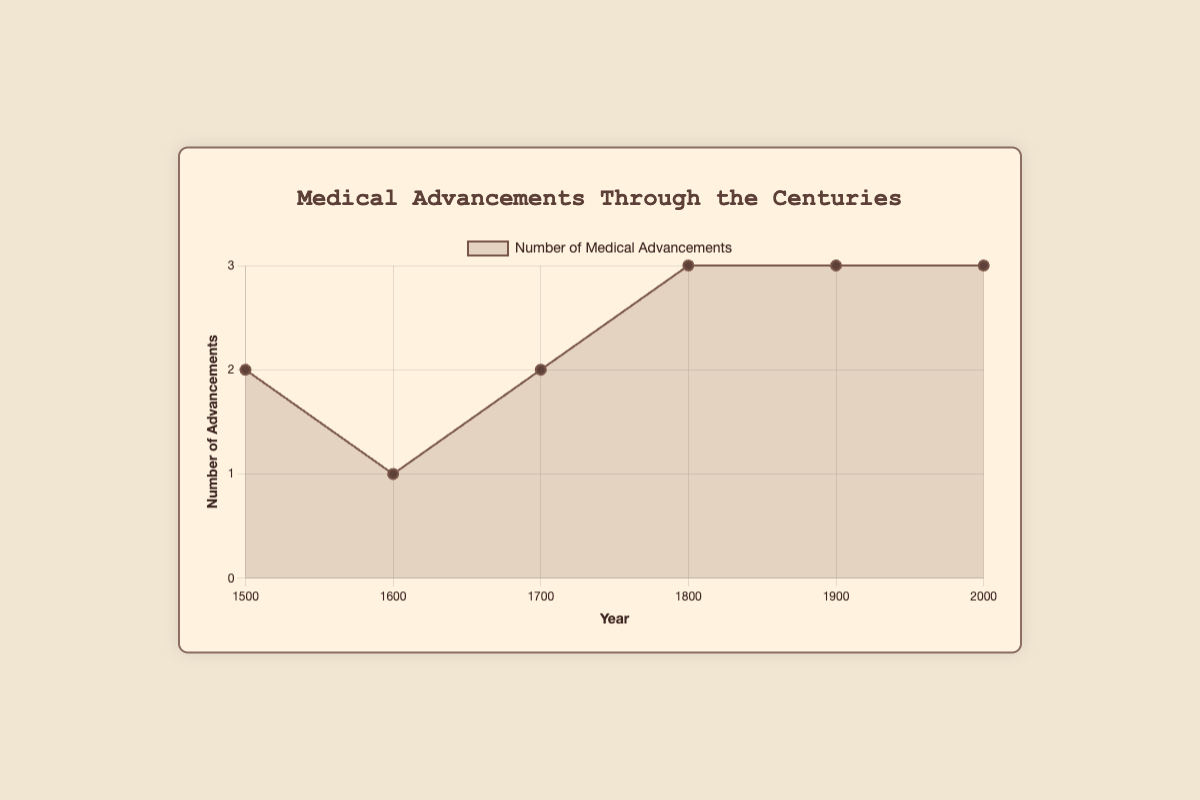What's the trend in the number of medical advancements from the year 1500 to 2000? Look at the line chart, it shows an increasing trend in the number of medical advancements over the centuries. It starts with 2 advancements around 1500, rising to 3 by 1800, and peaking at 3 in 1900 and 2000.
Answer: Increasing Which century saw the greatest increase in the number of medical advancements compared to the previous century? Compare the differences in the number of advancements between consecutive centuries visible in the line chart. From 1600 to 1700, it increases by 1 advancement; from 1700 to 1800, it increases by 1 more advancement; from 1800 to 1900, it increases by 1 advancement; and from 1900 to 2000, it remains the same. The century with the greatest increase is from 1500 to 1600 with an increase of 1.
Answer: From 1500 to 1600 How many medical innovations were introduced in the 20th century (1900s)? Refer to the y-axis value for the year 1900 in the line chart. Three innovations were introduced during this period.
Answer: Three Compare the number of medical advancements in the year 1500 and 1800. Which year had more, and by how much? Look at the y-axis values for both 1500 and 1800. The year 1500 had 2 advancements, and the year 1800 had 3 advancements. 1800 had one more advancement than 1500.
Answer: 1800 by 1 Was there any century with no recorded medical advancements? If so, which one? By inspecting the line chart, each century from 1500 to 2000 has at least one recorded medical advancement. Therefore, there is no century with zero advancements.
Answer: No What’s the average number of medical advancements per century from 1500 to 2000? Sum up the number of advancements from each century (2 + 1 + 2 + 3 + 3 + 3 = 14) and divide by the number of centuries (6). 14/6 ≈ 2.33.
Answer: 2.33 Which century had the fewest medical advancements, and how many were there? Look at the chart to find the lowest point on the y-axis. The 1600s had the fewest, with only one advancement.
Answer: 1600s with 1 Is there a year where the number of advancements is greater than 2 but less than 4? if so, which years are they? Refer to the chart to find years that have y-axis values between 2 and 4. The years 1800, 1900, and 2000 each have 3 advancements.
Answer: 1800, 1900, 2000 If you combine the advancements from 1700 and 1800, does the total exceed the combined advancements of 1600 and 1900? Calculate the sums: 1700 (2) + 1800 (3) = 5 and 1600 (1) + 1900 (3) = 4, 5 is greater than 4.
Answer: Yes What visual cue on the chart indicates the points where medical advancements occurred? The chart highlights the points with small circles along the line indicating the number of advancements for each year. The points form a line across the chart depicting the trend.
Answer: Small circles 